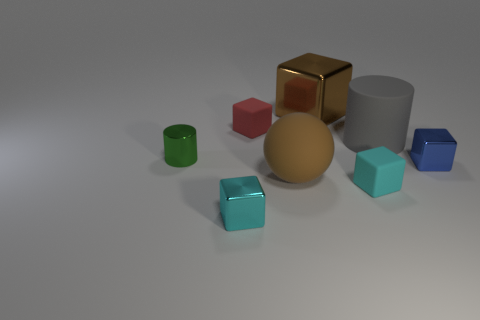Subtract all big cubes. How many cubes are left? 4 Subtract all red cubes. How many cubes are left? 4 Subtract 2 blocks. How many blocks are left? 3 Subtract all gray cubes. Subtract all blue cylinders. How many cubes are left? 5 Add 2 large red matte spheres. How many objects exist? 10 Subtract all cylinders. How many objects are left? 6 Add 8 small blue shiny objects. How many small blue shiny objects are left? 9 Add 6 brown matte balls. How many brown matte balls exist? 7 Subtract 0 blue cylinders. How many objects are left? 8 Subtract all big cyan matte cylinders. Subtract all cyan matte cubes. How many objects are left? 7 